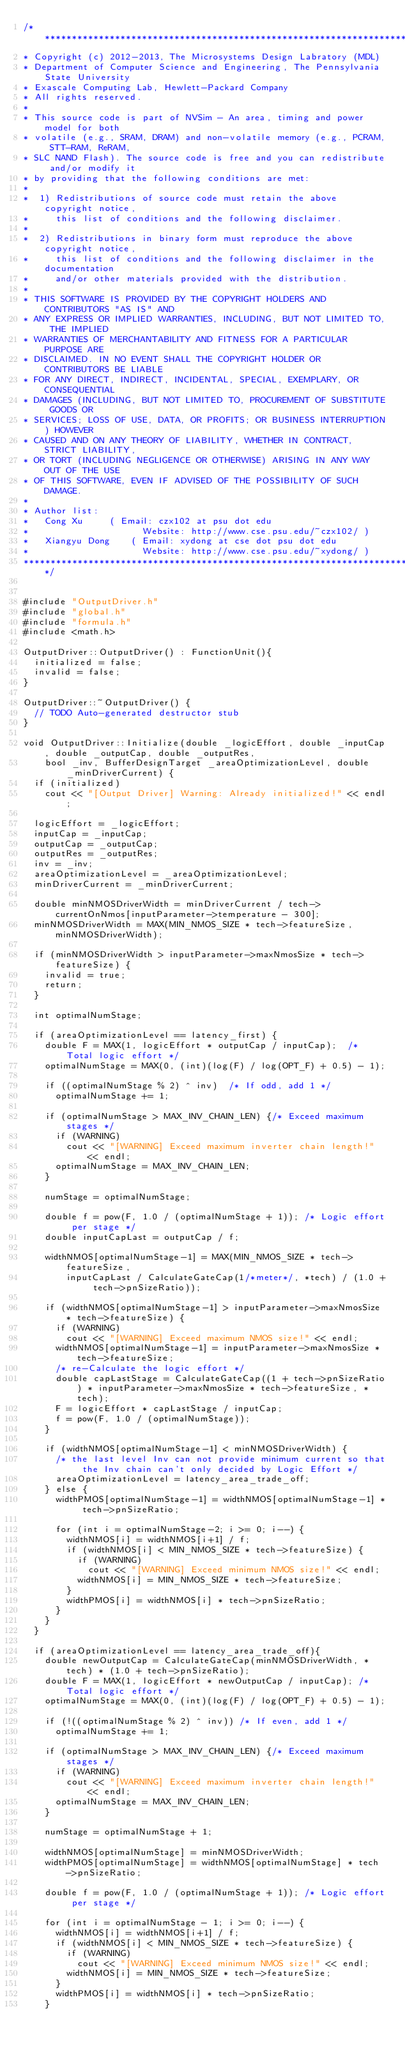Convert code to text. <code><loc_0><loc_0><loc_500><loc_500><_C++_>/*******************************************************************************
* Copyright (c) 2012-2013, The Microsystems Design Labratory (MDL)
* Department of Computer Science and Engineering, The Pennsylvania State University
* Exascale Computing Lab, Hewlett-Packard Company
* All rights reserved.
* 
* This source code is part of NVSim - An area, timing and power model for both 
* volatile (e.g., SRAM, DRAM) and non-volatile memory (e.g., PCRAM, STT-RAM, ReRAM, 
* SLC NAND Flash). The source code is free and you can redistribute and/or modify it
* by providing that the following conditions are met:
* 
*  1) Redistributions of source code must retain the above copyright notice,
*     this list of conditions and the following disclaimer.
* 
*  2) Redistributions in binary form must reproduce the above copyright notice,
*     this list of conditions and the following disclaimer in the documentation
*     and/or other materials provided with the distribution.
* 
* THIS SOFTWARE IS PROVIDED BY THE COPYRIGHT HOLDERS AND CONTRIBUTORS "AS IS" AND
* ANY EXPRESS OR IMPLIED WARRANTIES, INCLUDING, BUT NOT LIMITED TO, THE IMPLIED
* WARRANTIES OF MERCHANTABILITY AND FITNESS FOR A PARTICULAR PURPOSE ARE
* DISCLAIMED. IN NO EVENT SHALL THE COPYRIGHT HOLDER OR CONTRIBUTORS BE LIABLE
* FOR ANY DIRECT, INDIRECT, INCIDENTAL, SPECIAL, EXEMPLARY, OR CONSEQUENTIAL
* DAMAGES (INCLUDING, BUT NOT LIMITED TO, PROCUREMENT OF SUBSTITUTE GOODS OR
* SERVICES; LOSS OF USE, DATA, OR PROFITS; OR BUSINESS INTERRUPTION) HOWEVER
* CAUSED AND ON ANY THEORY OF LIABILITY, WHETHER IN CONTRACT, STRICT LIABILITY,
* OR TORT (INCLUDING NEGLIGENCE OR OTHERWISE) ARISING IN ANY WAY OUT OF THE USE
* OF THIS SOFTWARE, EVEN IF ADVISED OF THE POSSIBILITY OF SUCH DAMAGE.
* 
* Author list: 
*   Cong Xu	    ( Email: czx102 at psu dot edu 
*                     Website: http://www.cse.psu.edu/~czx102/ )
*   Xiangyu Dong    ( Email: xydong at cse dot psu dot edu
*                     Website: http://www.cse.psu.edu/~xydong/ )
*******************************************************************************/


#include "OutputDriver.h"
#include "global.h"
#include "formula.h"
#include <math.h>

OutputDriver::OutputDriver() : FunctionUnit(){
	initialized = false;
	invalid = false;
}

OutputDriver::~OutputDriver() {
	// TODO Auto-generated destructor stub
}

void OutputDriver::Initialize(double _logicEffort, double _inputCap, double _outputCap, double _outputRes,
		bool _inv, BufferDesignTarget _areaOptimizationLevel, double _minDriverCurrent) {
	if (initialized)
		cout << "[Output Driver] Warning: Already initialized!" << endl;

	logicEffort = _logicEffort;
	inputCap = _inputCap;
	outputCap = _outputCap;
	outputRes = _outputRes;
	inv = _inv;
	areaOptimizationLevel = _areaOptimizationLevel;
	minDriverCurrent = _minDriverCurrent;

	double minNMOSDriverWidth = minDriverCurrent / tech->currentOnNmos[inputParameter->temperature - 300];
	minNMOSDriverWidth = MAX(MIN_NMOS_SIZE * tech->featureSize, minNMOSDriverWidth);

	if (minNMOSDriverWidth > inputParameter->maxNmosSize * tech->featureSize) {
		invalid = true;
		return;
	}

	int optimalNumStage;

	if (areaOptimizationLevel == latency_first) {
		double F = MAX(1, logicEffort * outputCap / inputCap);	/* Total logic effort */
		optimalNumStage = MAX(0, (int)(log(F) / log(OPT_F) + 0.5) - 1);

		if ((optimalNumStage % 2) ^ inv)	/* If odd, add 1 */
			optimalNumStage += 1;

		if (optimalNumStage > MAX_INV_CHAIN_LEN) {/* Exceed maximum stages */
			if (WARNING)
				cout << "[WARNING] Exceed maximum inverter chain length!" << endl;
			optimalNumStage = MAX_INV_CHAIN_LEN;
		}

		numStage = optimalNumStage;

		double f = pow(F, 1.0 / (optimalNumStage + 1));	/* Logic effort per stage */
		double inputCapLast = outputCap / f;

		widthNMOS[optimalNumStage-1] = MAX(MIN_NMOS_SIZE * tech->featureSize,
				inputCapLast / CalculateGateCap(1/*meter*/, *tech) / (1.0 + tech->pnSizeRatio));

		if (widthNMOS[optimalNumStage-1] > inputParameter->maxNmosSize * tech->featureSize) {
			if (WARNING)
				cout << "[WARNING] Exceed maximum NMOS size!" << endl;
			widthNMOS[optimalNumStage-1] = inputParameter->maxNmosSize * tech->featureSize;
			/* re-Calculate the logic effort */
			double capLastStage = CalculateGateCap((1 + tech->pnSizeRatio) * inputParameter->maxNmosSize * tech->featureSize, *tech);
			F = logicEffort * capLastStage / inputCap;
			f =	pow(F, 1.0 / (optimalNumStage));
		}

		if (widthNMOS[optimalNumStage-1] < minNMOSDriverWidth) {
			/* the last level Inv can not provide minimum current so that the Inv chain can't only decided by Logic Effort */
			areaOptimizationLevel = latency_area_trade_off;
		} else {
			widthPMOS[optimalNumStage-1] = widthNMOS[optimalNumStage-1] * tech->pnSizeRatio;

			for (int i = optimalNumStage-2; i >= 0; i--) {
				widthNMOS[i] = widthNMOS[i+1] / f;
				if (widthNMOS[i] < MIN_NMOS_SIZE * tech->featureSize) {
					if (WARNING)
						cout << "[WARNING] Exceed minimum NMOS size!" << endl;
					widthNMOS[i] = MIN_NMOS_SIZE * tech->featureSize;
				}
				widthPMOS[i] = widthNMOS[i] * tech->pnSizeRatio;
			}
		}
	}

	if (areaOptimizationLevel == latency_area_trade_off){
		double newOutputCap = CalculateGateCap(minNMOSDriverWidth, *tech) * (1.0 + tech->pnSizeRatio);
		double F = MAX(1, logicEffort * newOutputCap / inputCap);	/* Total logic effort */
		optimalNumStage = MAX(0, (int)(log(F) / log(OPT_F) + 0.5) - 1);

		if (!((optimalNumStage % 2) ^ inv))	/* If even, add 1 */
			optimalNumStage += 1;

		if (optimalNumStage > MAX_INV_CHAIN_LEN) {/* Exceed maximum stages */
			if (WARNING)
				cout << "[WARNING] Exceed maximum inverter chain length!" << endl;
			optimalNumStage = MAX_INV_CHAIN_LEN;
		}

		numStage = optimalNumStage + 1;

		widthNMOS[optimalNumStage] = minNMOSDriverWidth;
		widthPMOS[optimalNumStage] = widthNMOS[optimalNumStage] * tech->pnSizeRatio;

		double f = pow(F, 1.0 / (optimalNumStage + 1));	/* Logic effort per stage */

		for (int i = optimalNumStage - 1; i >= 0; i--) {
			widthNMOS[i] = widthNMOS[i+1] / f;
			if (widthNMOS[i] < MIN_NMOS_SIZE * tech->featureSize) {
				if (WARNING)
					cout << "[WARNING] Exceed minimum NMOS size!" << endl;
				widthNMOS[i] = MIN_NMOS_SIZE * tech->featureSize;
			}
			widthPMOS[i] = widthNMOS[i] * tech->pnSizeRatio;
		}</code> 